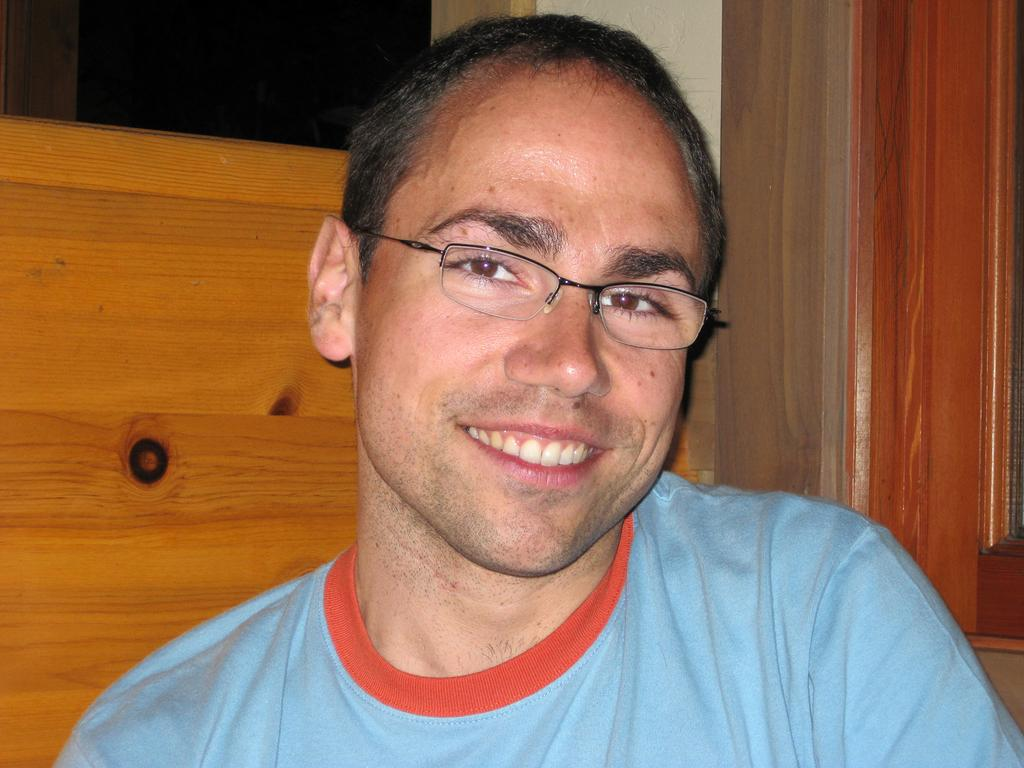Who is present in the image? There is a man in the image. What is the man doing in the image? The man is smiling in the image. What is the man wearing in the image? The man is wearing a blue T-shirt in the image. What can be seen in the background of the image? There is a wall in the background of the image, and there appears to be a window on the right side of the image. What type of bubble can be seen floating near the man in the image? There is no bubble present in the image; it only features a man, a wall, and a window. 